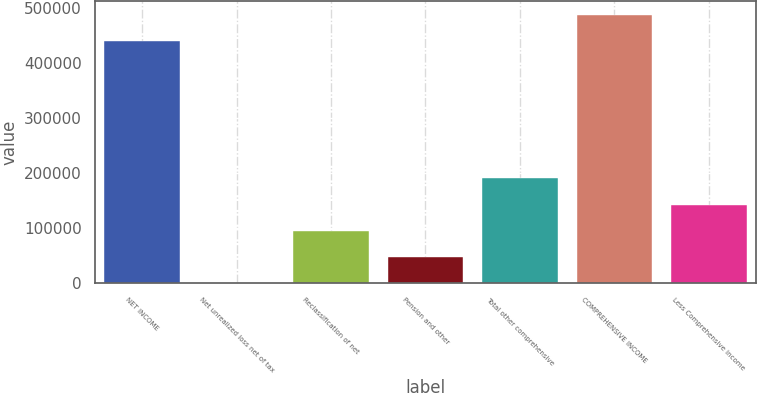<chart> <loc_0><loc_0><loc_500><loc_500><bar_chart><fcel>NET INCOME<fcel>Net unrealized loss net of tax<fcel>Reclassification of net<fcel>Pension and other<fcel>Total other comprehensive<fcel>COMPREHENSIVE INCOME<fcel>Less Comprehensive income<nl><fcel>439966<fcel>213<fcel>95354.6<fcel>47783.8<fcel>190496<fcel>487537<fcel>142925<nl></chart> 